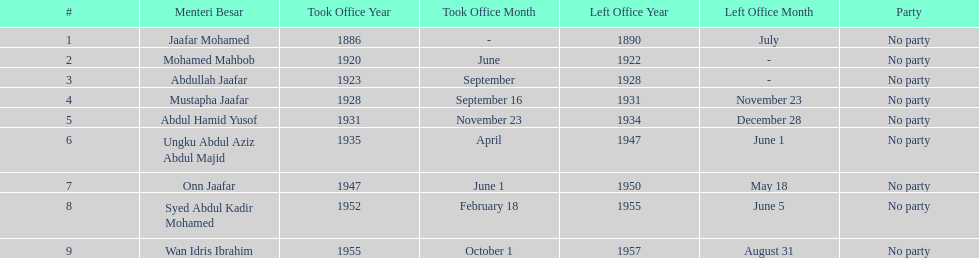How many years was jaafar mohamed in office? 4. 